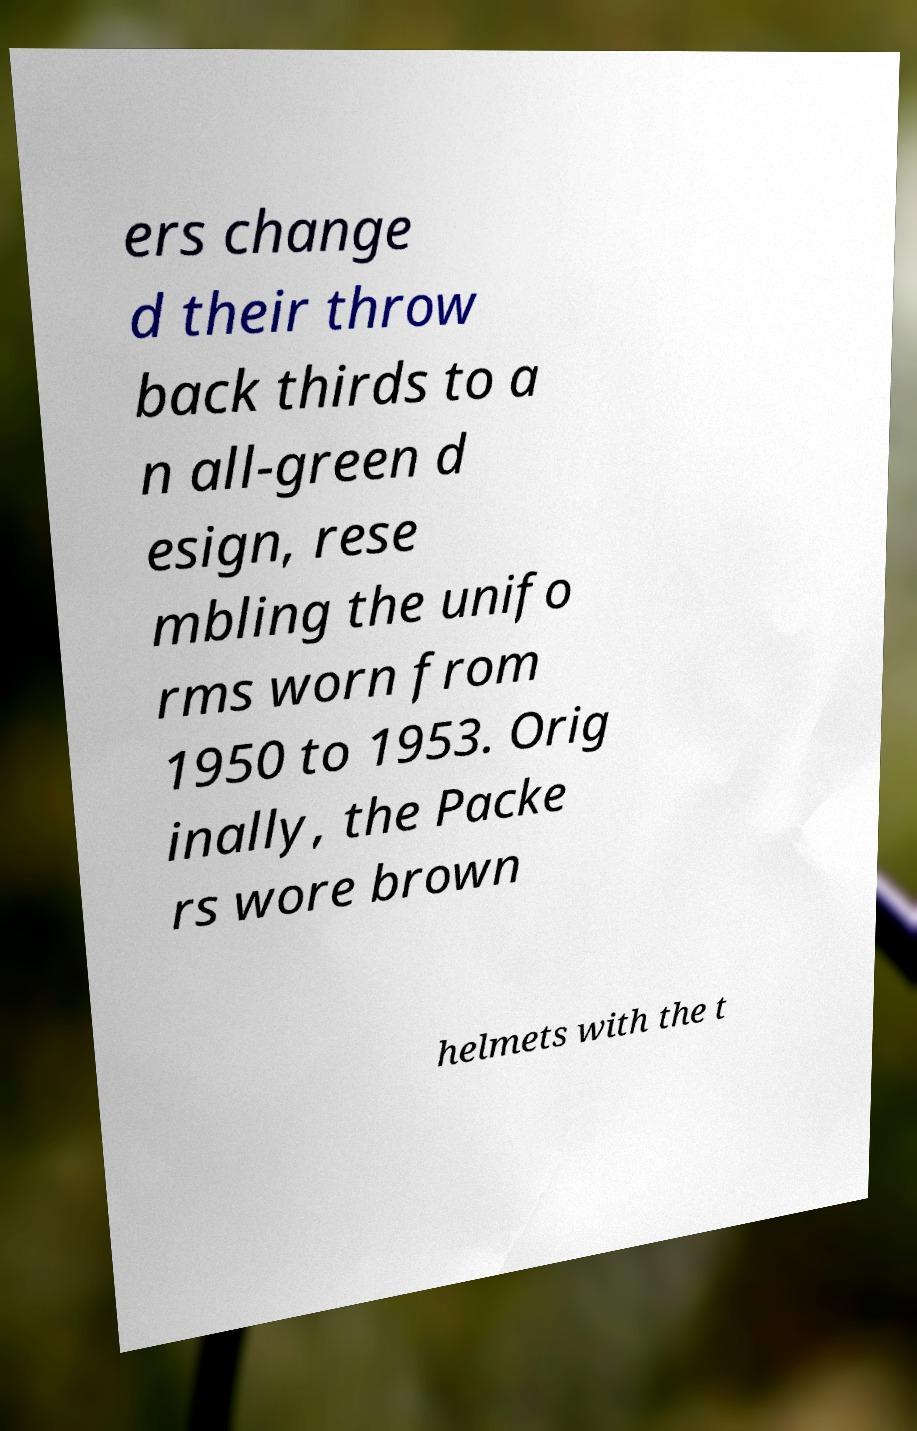What messages or text are displayed in this image? I need them in a readable, typed format. ers change d their throw back thirds to a n all-green d esign, rese mbling the unifo rms worn from 1950 to 1953. Orig inally, the Packe rs wore brown helmets with the t 